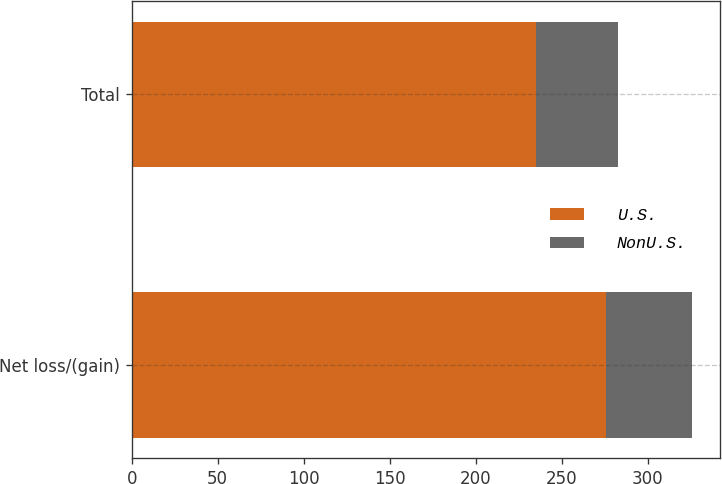Convert chart to OTSL. <chart><loc_0><loc_0><loc_500><loc_500><stacked_bar_chart><ecel><fcel>Net loss/(gain)<fcel>Total<nl><fcel>U.S.<fcel>276<fcel>235<nl><fcel>NonU.S.<fcel>50<fcel>48<nl></chart> 